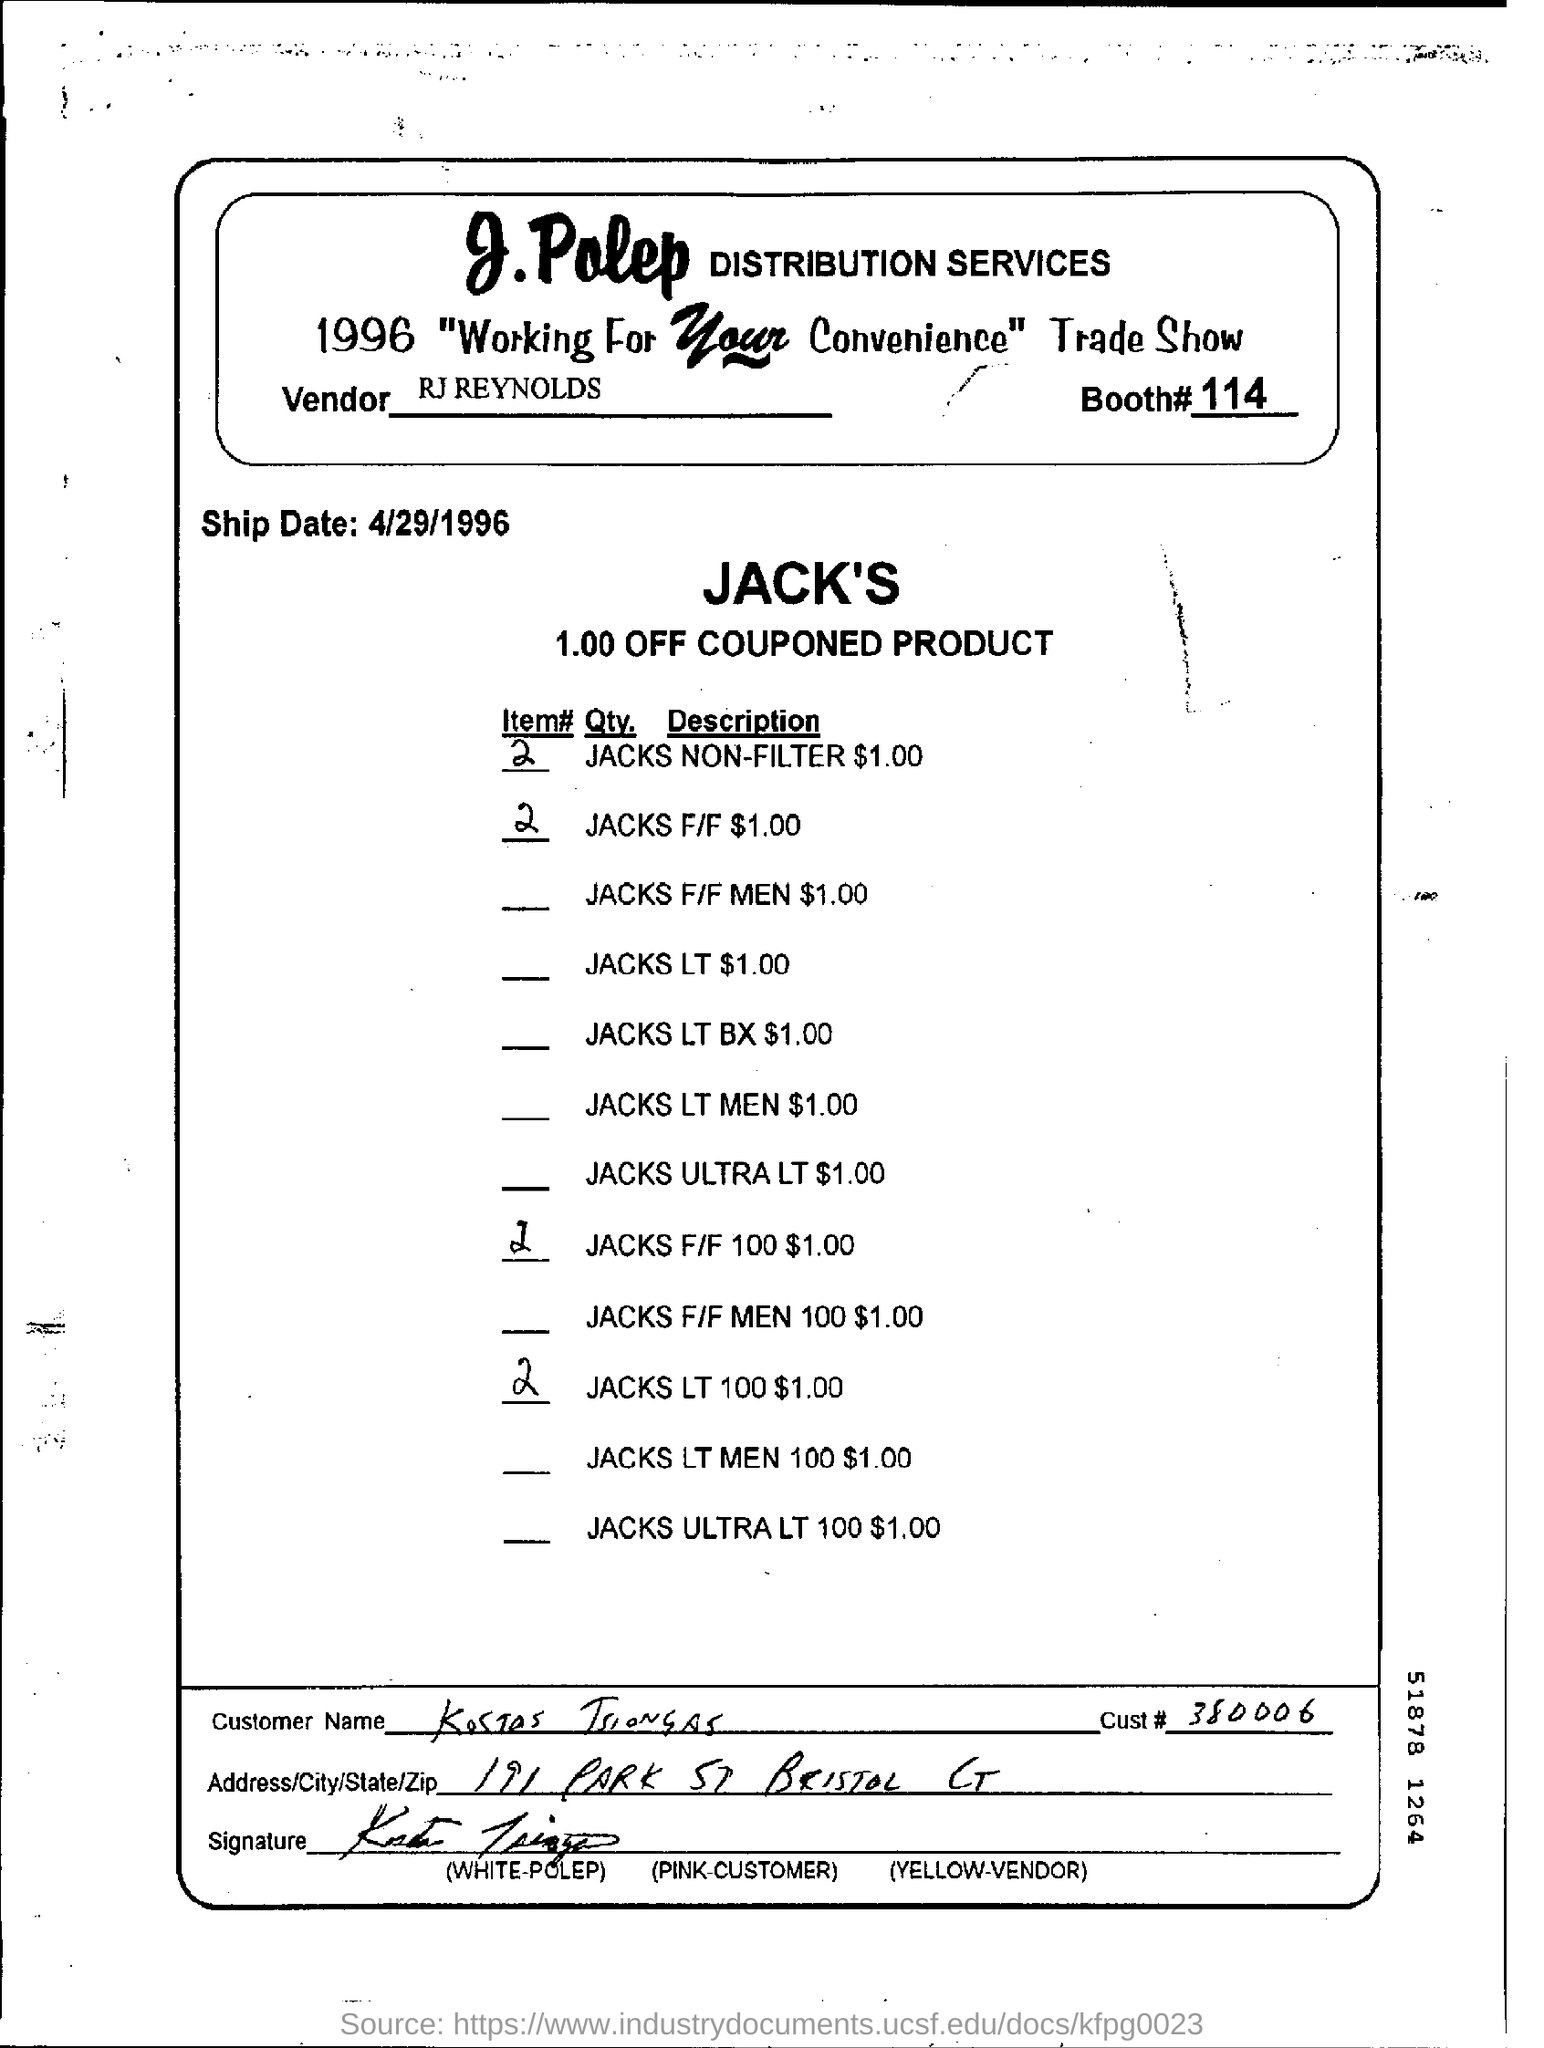What is the name of the distribution services?
Keep it short and to the point. J.Polep. What is the name of the trade show?
Provide a succinct answer. 1996 " working for your convenience " trade show. Who is the vendor?
Your answer should be very brief. RJ REYNOLDS. What is the booth number?
Offer a terse response. 114. What is the ship date?
Your response must be concise. 4/29/1996. What is the cust number?
Offer a terse response. 380006. What is the item number of JACKS F/F $ 1.00?
Provide a short and direct response. 2. 